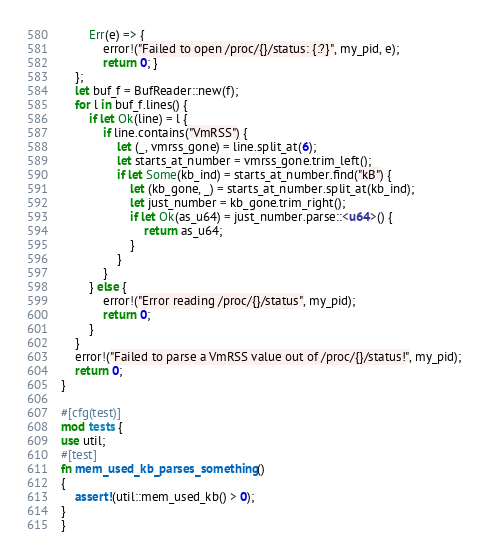Convert code to text. <code><loc_0><loc_0><loc_500><loc_500><_Rust_>        Err(e) => {
            error!("Failed to open /proc/{}/status: {:?}", my_pid, e);
            return 0; }
    };
    let buf_f = BufReader::new(f);
    for l in buf_f.lines() {
        if let Ok(line) = l {
            if line.contains("VmRSS") {
                let (_, vmrss_gone) = line.split_at(6);
                let starts_at_number = vmrss_gone.trim_left();
                if let Some(kb_ind) = starts_at_number.find("kB") {
                    let (kb_gone, _) = starts_at_number.split_at(kb_ind);
                    let just_number = kb_gone.trim_right();
                    if let Ok(as_u64) = just_number.parse::<u64>() {
                        return as_u64;
                    }
                }
            }
        } else {
            error!("Error reading /proc/{}/status", my_pid);
            return 0;
        }
    }
    error!("Failed to parse a VmRSS value out of /proc/{}/status!", my_pid);
    return 0;
}

#[cfg(test)]
mod tests {
use util;
#[test]
fn mem_used_kb_parses_something()
{
    assert!(util::mem_used_kb() > 0);
}
}
</code> 